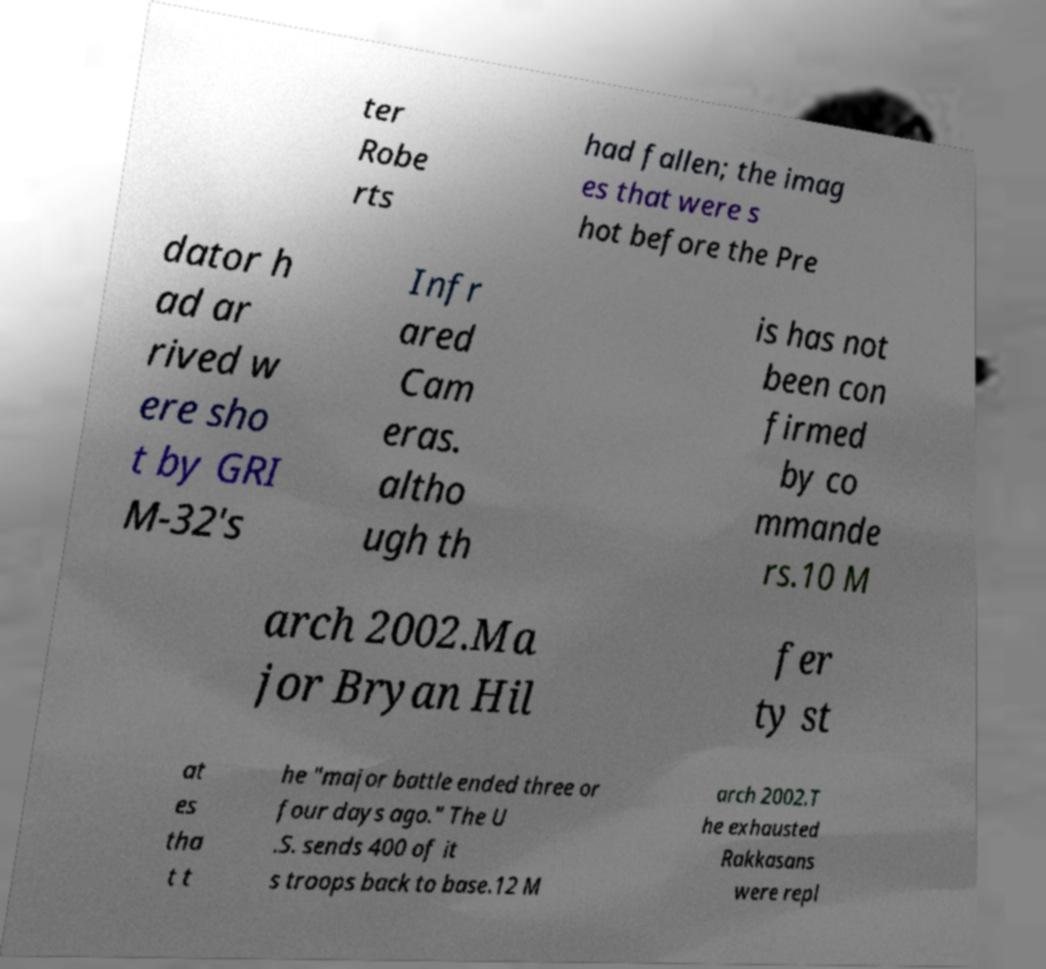For documentation purposes, I need the text within this image transcribed. Could you provide that? ter Robe rts had fallen; the imag es that were s hot before the Pre dator h ad ar rived w ere sho t by GRI M-32's Infr ared Cam eras. altho ugh th is has not been con firmed by co mmande rs.10 M arch 2002.Ma jor Bryan Hil fer ty st at es tha t t he "major battle ended three or four days ago." The U .S. sends 400 of it s troops back to base.12 M arch 2002.T he exhausted Rakkasans were repl 